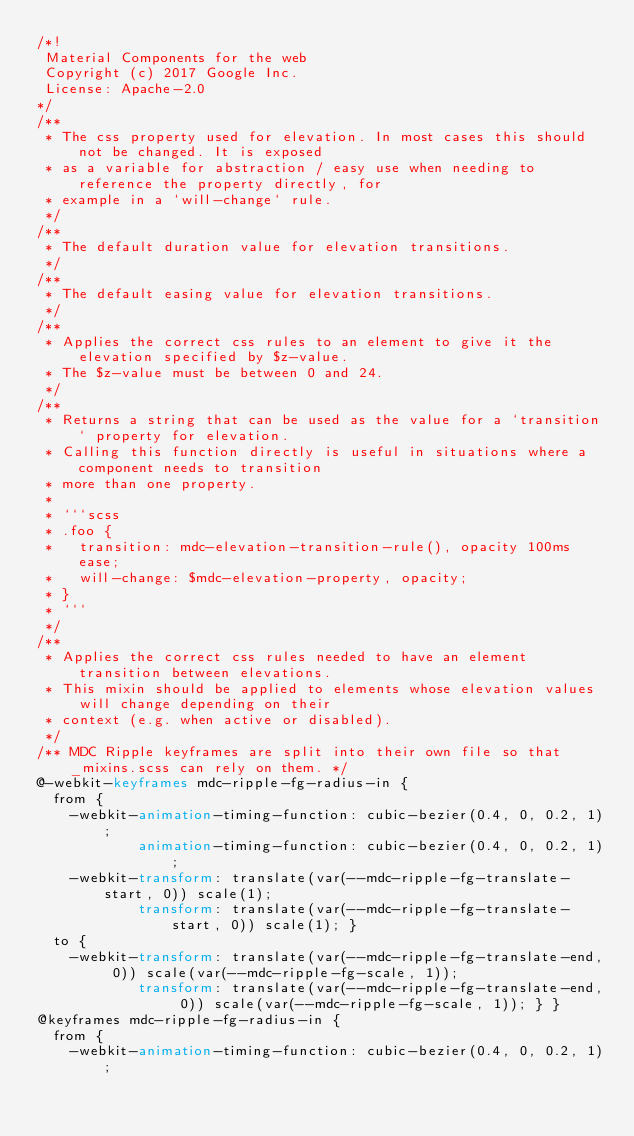Convert code to text. <code><loc_0><loc_0><loc_500><loc_500><_CSS_>/*!
 Material Components for the web
 Copyright (c) 2017 Google Inc.
 License: Apache-2.0
*/
/**
 * The css property used for elevation. In most cases this should not be changed. It is exposed
 * as a variable for abstraction / easy use when needing to reference the property directly, for
 * example in a `will-change` rule.
 */
/**
 * The default duration value for elevation transitions.
 */
/**
 * The default easing value for elevation transitions.
 */
/**
 * Applies the correct css rules to an element to give it the elevation specified by $z-value.
 * The $z-value must be between 0 and 24.
 */
/**
 * Returns a string that can be used as the value for a `transition` property for elevation.
 * Calling this function directly is useful in situations where a component needs to transition
 * more than one property.
 *
 * ```scss
 * .foo {
 *   transition: mdc-elevation-transition-rule(), opacity 100ms ease;
 *   will-change: $mdc-elevation-property, opacity;
 * }
 * ```
 */
/**
 * Applies the correct css rules needed to have an element transition between elevations.
 * This mixin should be applied to elements whose elevation values will change depending on their
 * context (e.g. when active or disabled).
 */
/** MDC Ripple keyframes are split into their own file so that _mixins.scss can rely on them. */
@-webkit-keyframes mdc-ripple-fg-radius-in {
  from {
    -webkit-animation-timing-function: cubic-bezier(0.4, 0, 0.2, 1);
            animation-timing-function: cubic-bezier(0.4, 0, 0.2, 1);
    -webkit-transform: translate(var(--mdc-ripple-fg-translate-start, 0)) scale(1);
            transform: translate(var(--mdc-ripple-fg-translate-start, 0)) scale(1); }
  to {
    -webkit-transform: translate(var(--mdc-ripple-fg-translate-end, 0)) scale(var(--mdc-ripple-fg-scale, 1));
            transform: translate(var(--mdc-ripple-fg-translate-end, 0)) scale(var(--mdc-ripple-fg-scale, 1)); } }
@keyframes mdc-ripple-fg-radius-in {
  from {
    -webkit-animation-timing-function: cubic-bezier(0.4, 0, 0.2, 1);</code> 